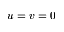<formula> <loc_0><loc_0><loc_500><loc_500>u = v = 0</formula> 